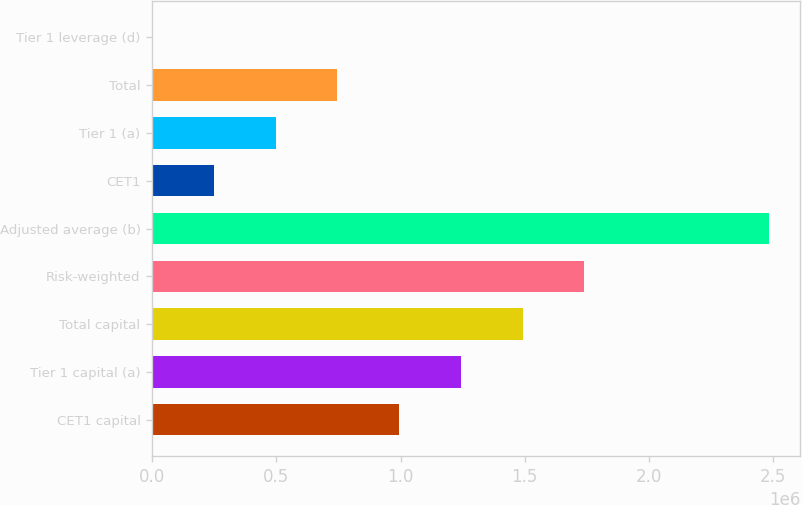<chart> <loc_0><loc_0><loc_500><loc_500><bar_chart><fcel>CET1 capital<fcel>Tier 1 capital (a)<fcel>Total capital<fcel>Risk-weighted<fcel>Adjusted average (b)<fcel>CET1<fcel>Tier 1 (a)<fcel>Total<fcel>Tier 1 leverage (d)<nl><fcel>993857<fcel>1.24232e+06<fcel>1.49078e+06<fcel>1.73924e+06<fcel>2.48463e+06<fcel>248471<fcel>496933<fcel>745395<fcel>8.4<nl></chart> 